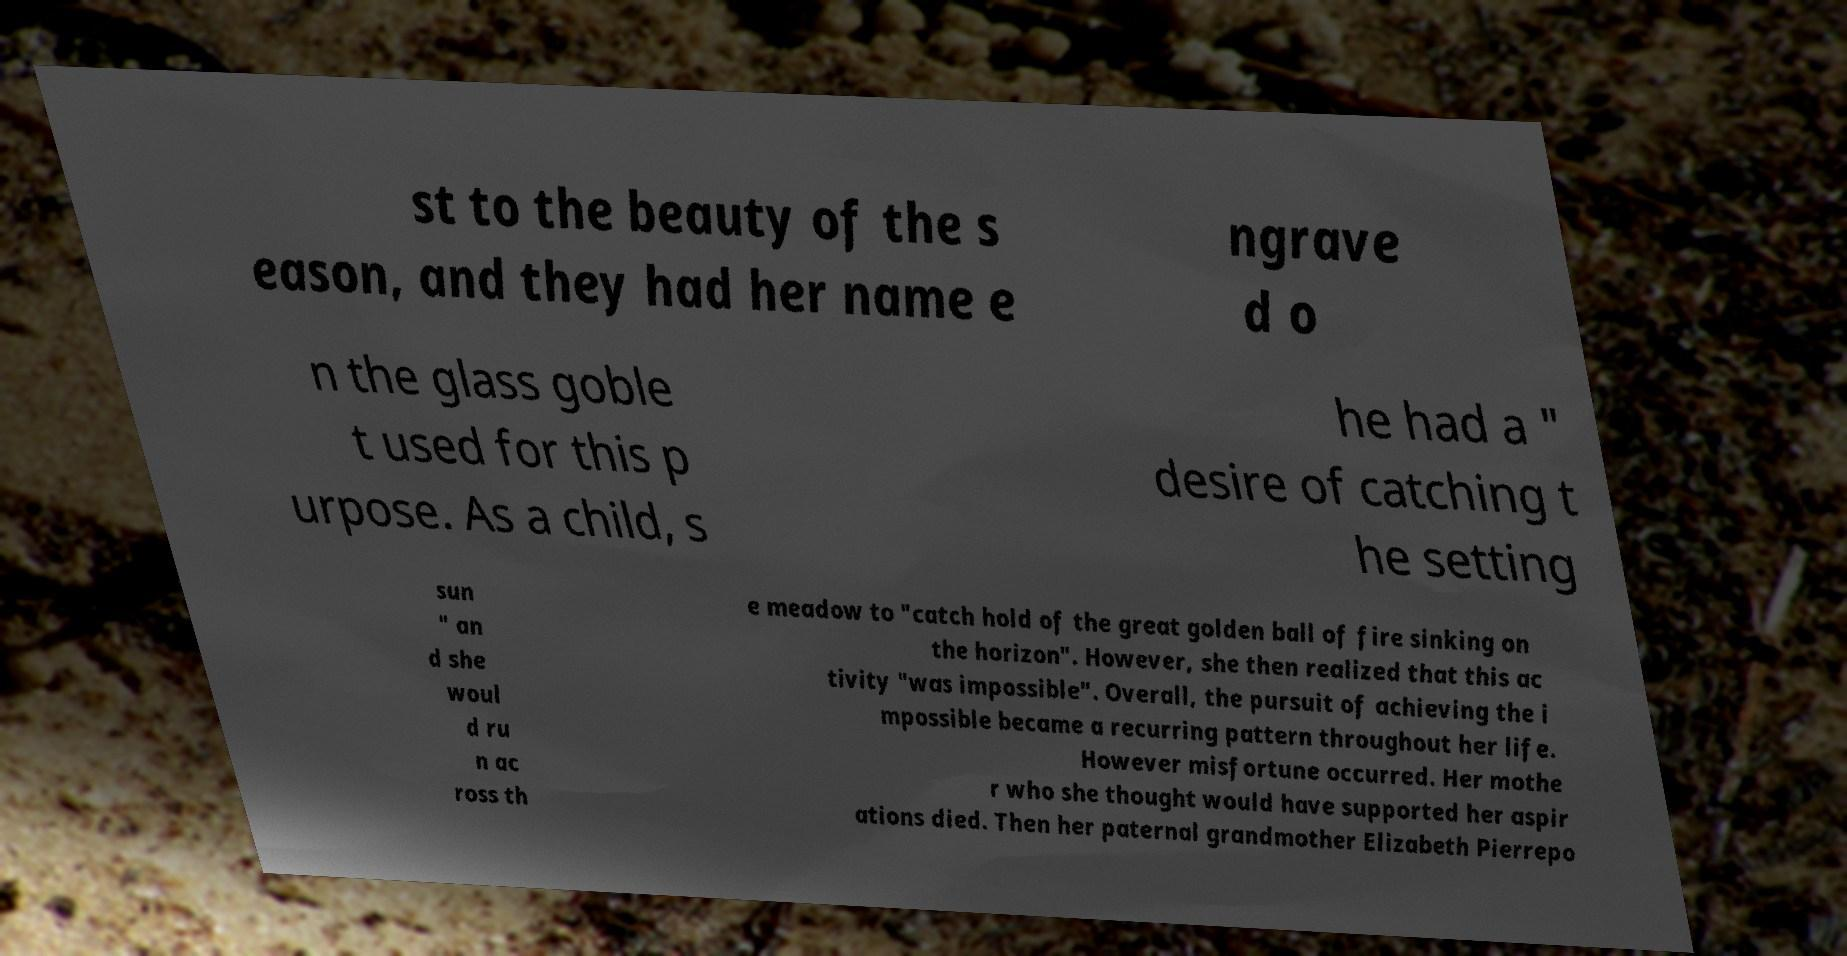Please read and relay the text visible in this image. What does it say? st to the beauty of the s eason, and they had her name e ngrave d o n the glass goble t used for this p urpose. As a child, s he had a " desire of catching t he setting sun " an d she woul d ru n ac ross th e meadow to "catch hold of the great golden ball of fire sinking on the horizon". However, she then realized that this ac tivity "was impossible". Overall, the pursuit of achieving the i mpossible became a recurring pattern throughout her life. However misfortune occurred. Her mothe r who she thought would have supported her aspir ations died. Then her paternal grandmother Elizabeth Pierrepo 